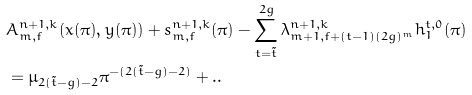<formula> <loc_0><loc_0><loc_500><loc_500>& A ^ { n + 1 , k } _ { m , f } ( x ( \pi ) , y ( \pi ) ) + s ^ { n + 1 , k } _ { m , f } ( \pi ) - \sum _ { t = \tilde { t } } ^ { 2 g } \lambda ^ { n + 1 , k } _ { m + 1 , f + ( t - 1 ) ( 2 g ) ^ { m } } h ^ { t , 0 } _ { 1 } ( \pi ) \\ & = \mu _ { 2 ( \tilde { t } - g ) - 2 } \pi ^ { - ( 2 ( \tilde { t } - g ) - 2 ) } + . .</formula> 